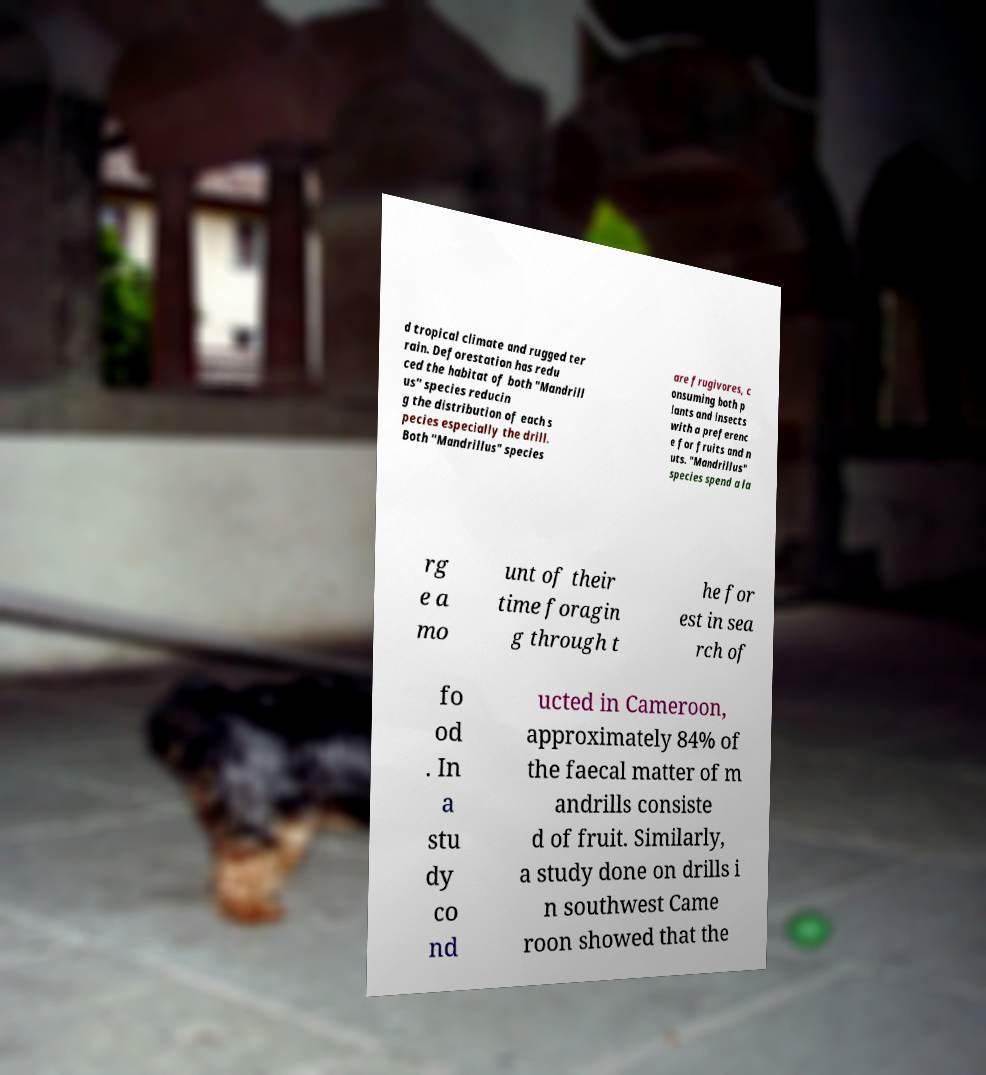Could you assist in decoding the text presented in this image and type it out clearly? d tropical climate and rugged ter rain. Deforestation has redu ced the habitat of both "Mandrill us" species reducin g the distribution of each s pecies especially the drill. Both "Mandrillus" species are frugivores, c onsuming both p lants and insects with a preferenc e for fruits and n uts. "Mandrillus" species spend a la rg e a mo unt of their time foragin g through t he for est in sea rch of fo od . In a stu dy co nd ucted in Cameroon, approximately 84% of the faecal matter of m andrills consiste d of fruit. Similarly, a study done on drills i n southwest Came roon showed that the 